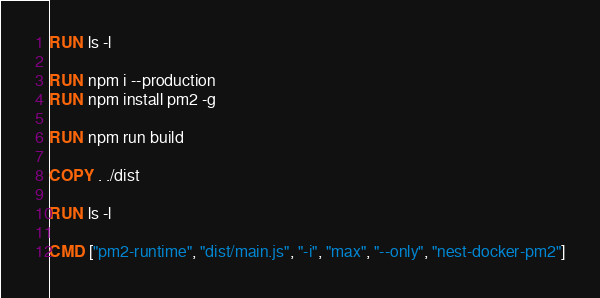Convert code to text. <code><loc_0><loc_0><loc_500><loc_500><_Dockerfile_>RUN ls -l

RUN npm i --production
RUN npm install pm2 -g

RUN npm run build

COPY . ./dist

RUN ls -l

CMD ["pm2-runtime", "dist/main.js", "-i", "max", "--only", "nest-docker-pm2"]

</code> 